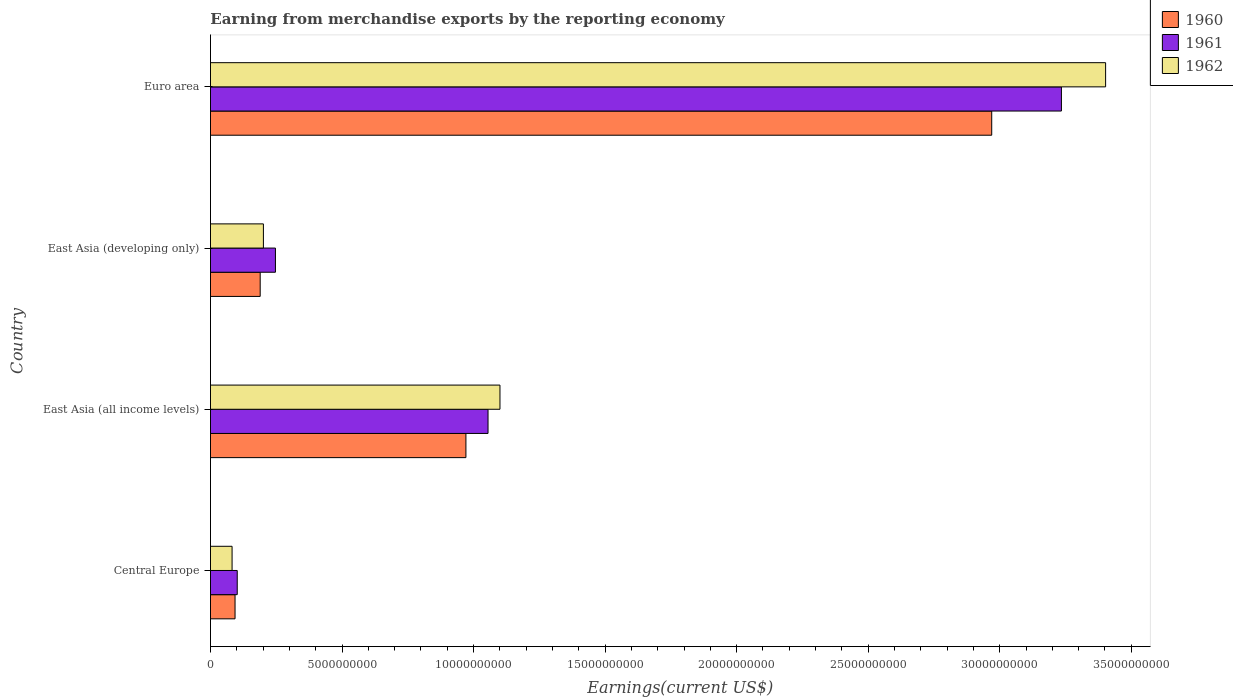Are the number of bars per tick equal to the number of legend labels?
Offer a very short reply. Yes. Are the number of bars on each tick of the Y-axis equal?
Make the answer very short. Yes. How many bars are there on the 3rd tick from the top?
Your answer should be very brief. 3. What is the label of the 1st group of bars from the top?
Ensure brevity in your answer.  Euro area. In how many cases, is the number of bars for a given country not equal to the number of legend labels?
Provide a short and direct response. 0. What is the amount earned from merchandise exports in 1962 in Central Europe?
Your response must be concise. 8.21e+08. Across all countries, what is the maximum amount earned from merchandise exports in 1961?
Give a very brief answer. 3.23e+1. Across all countries, what is the minimum amount earned from merchandise exports in 1961?
Provide a short and direct response. 1.02e+09. In which country was the amount earned from merchandise exports in 1961 minimum?
Make the answer very short. Central Europe. What is the total amount earned from merchandise exports in 1962 in the graph?
Provide a succinct answer. 4.79e+1. What is the difference between the amount earned from merchandise exports in 1961 in Central Europe and that in East Asia (all income levels)?
Offer a very short reply. -9.53e+09. What is the difference between the amount earned from merchandise exports in 1961 in Euro area and the amount earned from merchandise exports in 1960 in Central Europe?
Give a very brief answer. 3.14e+1. What is the average amount earned from merchandise exports in 1960 per country?
Your response must be concise. 1.06e+1. What is the difference between the amount earned from merchandise exports in 1962 and amount earned from merchandise exports in 1960 in East Asia (developing only)?
Your answer should be very brief. 1.22e+08. In how many countries, is the amount earned from merchandise exports in 1962 greater than 27000000000 US$?
Your answer should be compact. 1. What is the ratio of the amount earned from merchandise exports in 1962 in Central Europe to that in Euro area?
Provide a succinct answer. 0.02. What is the difference between the highest and the second highest amount earned from merchandise exports in 1961?
Keep it short and to the point. 2.18e+1. What is the difference between the highest and the lowest amount earned from merchandise exports in 1960?
Give a very brief answer. 2.88e+1. What does the 1st bar from the top in Central Europe represents?
Make the answer very short. 1962. Is it the case that in every country, the sum of the amount earned from merchandise exports in 1961 and amount earned from merchandise exports in 1962 is greater than the amount earned from merchandise exports in 1960?
Your response must be concise. Yes. How many bars are there?
Offer a very short reply. 12. How many countries are there in the graph?
Your response must be concise. 4. What is the difference between two consecutive major ticks on the X-axis?
Your answer should be very brief. 5.00e+09. Are the values on the major ticks of X-axis written in scientific E-notation?
Offer a very short reply. No. Does the graph contain any zero values?
Ensure brevity in your answer.  No. Where does the legend appear in the graph?
Your response must be concise. Top right. How many legend labels are there?
Your answer should be very brief. 3. How are the legend labels stacked?
Provide a succinct answer. Vertical. What is the title of the graph?
Ensure brevity in your answer.  Earning from merchandise exports by the reporting economy. What is the label or title of the X-axis?
Ensure brevity in your answer.  Earnings(current US$). What is the label or title of the Y-axis?
Keep it short and to the point. Country. What is the Earnings(current US$) in 1960 in Central Europe?
Your answer should be very brief. 9.34e+08. What is the Earnings(current US$) in 1961 in Central Europe?
Offer a terse response. 1.02e+09. What is the Earnings(current US$) of 1962 in Central Europe?
Offer a very short reply. 8.21e+08. What is the Earnings(current US$) of 1960 in East Asia (all income levels)?
Make the answer very short. 9.71e+09. What is the Earnings(current US$) of 1961 in East Asia (all income levels)?
Ensure brevity in your answer.  1.06e+1. What is the Earnings(current US$) of 1962 in East Asia (all income levels)?
Your answer should be very brief. 1.10e+1. What is the Earnings(current US$) in 1960 in East Asia (developing only)?
Offer a terse response. 1.89e+09. What is the Earnings(current US$) of 1961 in East Asia (developing only)?
Provide a succinct answer. 2.47e+09. What is the Earnings(current US$) of 1962 in East Asia (developing only)?
Your answer should be very brief. 2.01e+09. What is the Earnings(current US$) of 1960 in Euro area?
Give a very brief answer. 2.97e+1. What is the Earnings(current US$) of 1961 in Euro area?
Make the answer very short. 3.23e+1. What is the Earnings(current US$) in 1962 in Euro area?
Give a very brief answer. 3.40e+1. Across all countries, what is the maximum Earnings(current US$) of 1960?
Offer a terse response. 2.97e+1. Across all countries, what is the maximum Earnings(current US$) in 1961?
Ensure brevity in your answer.  3.23e+1. Across all countries, what is the maximum Earnings(current US$) of 1962?
Ensure brevity in your answer.  3.40e+1. Across all countries, what is the minimum Earnings(current US$) of 1960?
Your response must be concise. 9.34e+08. Across all countries, what is the minimum Earnings(current US$) in 1961?
Your answer should be compact. 1.02e+09. Across all countries, what is the minimum Earnings(current US$) in 1962?
Give a very brief answer. 8.21e+08. What is the total Earnings(current US$) of 1960 in the graph?
Provide a succinct answer. 4.22e+1. What is the total Earnings(current US$) of 1961 in the graph?
Make the answer very short. 4.64e+1. What is the total Earnings(current US$) of 1962 in the graph?
Your answer should be very brief. 4.79e+1. What is the difference between the Earnings(current US$) in 1960 in Central Europe and that in East Asia (all income levels)?
Keep it short and to the point. -8.78e+09. What is the difference between the Earnings(current US$) of 1961 in Central Europe and that in East Asia (all income levels)?
Provide a succinct answer. -9.53e+09. What is the difference between the Earnings(current US$) in 1962 in Central Europe and that in East Asia (all income levels)?
Your answer should be compact. -1.02e+1. What is the difference between the Earnings(current US$) of 1960 in Central Europe and that in East Asia (developing only)?
Make the answer very short. -9.55e+08. What is the difference between the Earnings(current US$) in 1961 in Central Europe and that in East Asia (developing only)?
Ensure brevity in your answer.  -1.45e+09. What is the difference between the Earnings(current US$) in 1962 in Central Europe and that in East Asia (developing only)?
Make the answer very short. -1.19e+09. What is the difference between the Earnings(current US$) in 1960 in Central Europe and that in Euro area?
Provide a succinct answer. -2.88e+1. What is the difference between the Earnings(current US$) of 1961 in Central Europe and that in Euro area?
Ensure brevity in your answer.  -3.13e+1. What is the difference between the Earnings(current US$) in 1962 in Central Europe and that in Euro area?
Offer a terse response. -3.32e+1. What is the difference between the Earnings(current US$) in 1960 in East Asia (all income levels) and that in East Asia (developing only)?
Your response must be concise. 7.82e+09. What is the difference between the Earnings(current US$) in 1961 in East Asia (all income levels) and that in East Asia (developing only)?
Offer a terse response. 8.08e+09. What is the difference between the Earnings(current US$) of 1962 in East Asia (all income levels) and that in East Asia (developing only)?
Offer a very short reply. 8.99e+09. What is the difference between the Earnings(current US$) in 1960 in East Asia (all income levels) and that in Euro area?
Offer a very short reply. -2.00e+1. What is the difference between the Earnings(current US$) in 1961 in East Asia (all income levels) and that in Euro area?
Keep it short and to the point. -2.18e+1. What is the difference between the Earnings(current US$) of 1962 in East Asia (all income levels) and that in Euro area?
Make the answer very short. -2.30e+1. What is the difference between the Earnings(current US$) in 1960 in East Asia (developing only) and that in Euro area?
Your answer should be compact. -2.78e+1. What is the difference between the Earnings(current US$) in 1961 in East Asia (developing only) and that in Euro area?
Your response must be concise. -2.99e+1. What is the difference between the Earnings(current US$) in 1962 in East Asia (developing only) and that in Euro area?
Offer a terse response. -3.20e+1. What is the difference between the Earnings(current US$) of 1960 in Central Europe and the Earnings(current US$) of 1961 in East Asia (all income levels)?
Offer a very short reply. -9.62e+09. What is the difference between the Earnings(current US$) in 1960 in Central Europe and the Earnings(current US$) in 1962 in East Asia (all income levels)?
Your response must be concise. -1.01e+1. What is the difference between the Earnings(current US$) in 1961 in Central Europe and the Earnings(current US$) in 1962 in East Asia (all income levels)?
Offer a very short reply. -9.99e+09. What is the difference between the Earnings(current US$) in 1960 in Central Europe and the Earnings(current US$) in 1961 in East Asia (developing only)?
Your answer should be compact. -1.54e+09. What is the difference between the Earnings(current US$) of 1960 in Central Europe and the Earnings(current US$) of 1962 in East Asia (developing only)?
Make the answer very short. -1.08e+09. What is the difference between the Earnings(current US$) in 1961 in Central Europe and the Earnings(current US$) in 1962 in East Asia (developing only)?
Your answer should be very brief. -9.95e+08. What is the difference between the Earnings(current US$) of 1960 in Central Europe and the Earnings(current US$) of 1961 in Euro area?
Provide a succinct answer. -3.14e+1. What is the difference between the Earnings(current US$) of 1960 in Central Europe and the Earnings(current US$) of 1962 in Euro area?
Offer a very short reply. -3.31e+1. What is the difference between the Earnings(current US$) in 1961 in Central Europe and the Earnings(current US$) in 1962 in Euro area?
Your answer should be very brief. -3.30e+1. What is the difference between the Earnings(current US$) of 1960 in East Asia (all income levels) and the Earnings(current US$) of 1961 in East Asia (developing only)?
Your response must be concise. 7.24e+09. What is the difference between the Earnings(current US$) in 1960 in East Asia (all income levels) and the Earnings(current US$) in 1962 in East Asia (developing only)?
Your answer should be very brief. 7.70e+09. What is the difference between the Earnings(current US$) in 1961 in East Asia (all income levels) and the Earnings(current US$) in 1962 in East Asia (developing only)?
Make the answer very short. 8.54e+09. What is the difference between the Earnings(current US$) in 1960 in East Asia (all income levels) and the Earnings(current US$) in 1961 in Euro area?
Your answer should be very brief. -2.26e+1. What is the difference between the Earnings(current US$) in 1960 in East Asia (all income levels) and the Earnings(current US$) in 1962 in Euro area?
Offer a terse response. -2.43e+1. What is the difference between the Earnings(current US$) in 1961 in East Asia (all income levels) and the Earnings(current US$) in 1962 in Euro area?
Ensure brevity in your answer.  -2.35e+1. What is the difference between the Earnings(current US$) in 1960 in East Asia (developing only) and the Earnings(current US$) in 1961 in Euro area?
Your answer should be compact. -3.05e+1. What is the difference between the Earnings(current US$) of 1960 in East Asia (developing only) and the Earnings(current US$) of 1962 in Euro area?
Your answer should be compact. -3.21e+1. What is the difference between the Earnings(current US$) of 1961 in East Asia (developing only) and the Earnings(current US$) of 1962 in Euro area?
Your answer should be very brief. -3.16e+1. What is the average Earnings(current US$) in 1960 per country?
Give a very brief answer. 1.06e+1. What is the average Earnings(current US$) of 1961 per country?
Provide a short and direct response. 1.16e+1. What is the average Earnings(current US$) in 1962 per country?
Your answer should be very brief. 1.20e+1. What is the difference between the Earnings(current US$) in 1960 and Earnings(current US$) in 1961 in Central Europe?
Make the answer very short. -8.30e+07. What is the difference between the Earnings(current US$) in 1960 and Earnings(current US$) in 1962 in Central Europe?
Ensure brevity in your answer.  1.13e+08. What is the difference between the Earnings(current US$) of 1961 and Earnings(current US$) of 1962 in Central Europe?
Your answer should be very brief. 1.96e+08. What is the difference between the Earnings(current US$) of 1960 and Earnings(current US$) of 1961 in East Asia (all income levels)?
Your answer should be compact. -8.41e+08. What is the difference between the Earnings(current US$) in 1960 and Earnings(current US$) in 1962 in East Asia (all income levels)?
Your answer should be compact. -1.29e+09. What is the difference between the Earnings(current US$) of 1961 and Earnings(current US$) of 1962 in East Asia (all income levels)?
Keep it short and to the point. -4.54e+08. What is the difference between the Earnings(current US$) in 1960 and Earnings(current US$) in 1961 in East Asia (developing only)?
Keep it short and to the point. -5.80e+08. What is the difference between the Earnings(current US$) of 1960 and Earnings(current US$) of 1962 in East Asia (developing only)?
Make the answer very short. -1.22e+08. What is the difference between the Earnings(current US$) of 1961 and Earnings(current US$) of 1962 in East Asia (developing only)?
Provide a short and direct response. 4.57e+08. What is the difference between the Earnings(current US$) of 1960 and Earnings(current US$) of 1961 in Euro area?
Your answer should be very brief. -2.65e+09. What is the difference between the Earnings(current US$) of 1960 and Earnings(current US$) of 1962 in Euro area?
Your answer should be very brief. -4.33e+09. What is the difference between the Earnings(current US$) in 1961 and Earnings(current US$) in 1962 in Euro area?
Ensure brevity in your answer.  -1.68e+09. What is the ratio of the Earnings(current US$) in 1960 in Central Europe to that in East Asia (all income levels)?
Keep it short and to the point. 0.1. What is the ratio of the Earnings(current US$) of 1961 in Central Europe to that in East Asia (all income levels)?
Your answer should be compact. 0.1. What is the ratio of the Earnings(current US$) of 1962 in Central Europe to that in East Asia (all income levels)?
Ensure brevity in your answer.  0.07. What is the ratio of the Earnings(current US$) of 1960 in Central Europe to that in East Asia (developing only)?
Offer a terse response. 0.49. What is the ratio of the Earnings(current US$) in 1961 in Central Europe to that in East Asia (developing only)?
Keep it short and to the point. 0.41. What is the ratio of the Earnings(current US$) of 1962 in Central Europe to that in East Asia (developing only)?
Keep it short and to the point. 0.41. What is the ratio of the Earnings(current US$) of 1960 in Central Europe to that in Euro area?
Offer a very short reply. 0.03. What is the ratio of the Earnings(current US$) of 1961 in Central Europe to that in Euro area?
Make the answer very short. 0.03. What is the ratio of the Earnings(current US$) of 1962 in Central Europe to that in Euro area?
Make the answer very short. 0.02. What is the ratio of the Earnings(current US$) in 1960 in East Asia (all income levels) to that in East Asia (developing only)?
Your answer should be compact. 5.14. What is the ratio of the Earnings(current US$) of 1961 in East Asia (all income levels) to that in East Asia (developing only)?
Your answer should be compact. 4.27. What is the ratio of the Earnings(current US$) in 1962 in East Asia (all income levels) to that in East Asia (developing only)?
Keep it short and to the point. 5.47. What is the ratio of the Earnings(current US$) in 1960 in East Asia (all income levels) to that in Euro area?
Make the answer very short. 0.33. What is the ratio of the Earnings(current US$) of 1961 in East Asia (all income levels) to that in Euro area?
Keep it short and to the point. 0.33. What is the ratio of the Earnings(current US$) in 1962 in East Asia (all income levels) to that in Euro area?
Offer a very short reply. 0.32. What is the ratio of the Earnings(current US$) in 1960 in East Asia (developing only) to that in Euro area?
Make the answer very short. 0.06. What is the ratio of the Earnings(current US$) of 1961 in East Asia (developing only) to that in Euro area?
Provide a short and direct response. 0.08. What is the ratio of the Earnings(current US$) of 1962 in East Asia (developing only) to that in Euro area?
Your answer should be very brief. 0.06. What is the difference between the highest and the second highest Earnings(current US$) of 1960?
Your response must be concise. 2.00e+1. What is the difference between the highest and the second highest Earnings(current US$) in 1961?
Offer a terse response. 2.18e+1. What is the difference between the highest and the second highest Earnings(current US$) in 1962?
Your answer should be compact. 2.30e+1. What is the difference between the highest and the lowest Earnings(current US$) of 1960?
Make the answer very short. 2.88e+1. What is the difference between the highest and the lowest Earnings(current US$) in 1961?
Offer a terse response. 3.13e+1. What is the difference between the highest and the lowest Earnings(current US$) in 1962?
Give a very brief answer. 3.32e+1. 